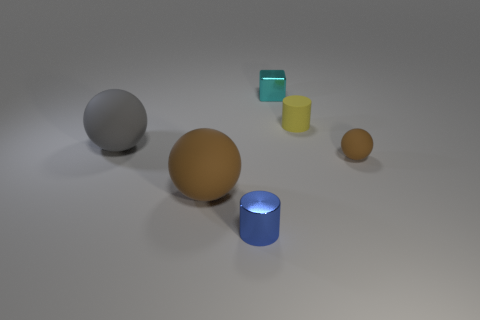Subtract all large matte balls. How many balls are left? 1 Subtract all cubes. How many objects are left? 5 Add 2 shiny cylinders. How many objects exist? 8 Subtract all yellow cylinders. How many cylinders are left? 1 Subtract 1 blocks. How many blocks are left? 0 Subtract all red cylinders. How many yellow blocks are left? 0 Subtract all gray matte things. Subtract all yellow objects. How many objects are left? 4 Add 5 big things. How many big things are left? 7 Add 1 large brown balls. How many large brown balls exist? 2 Subtract 1 cyan cubes. How many objects are left? 5 